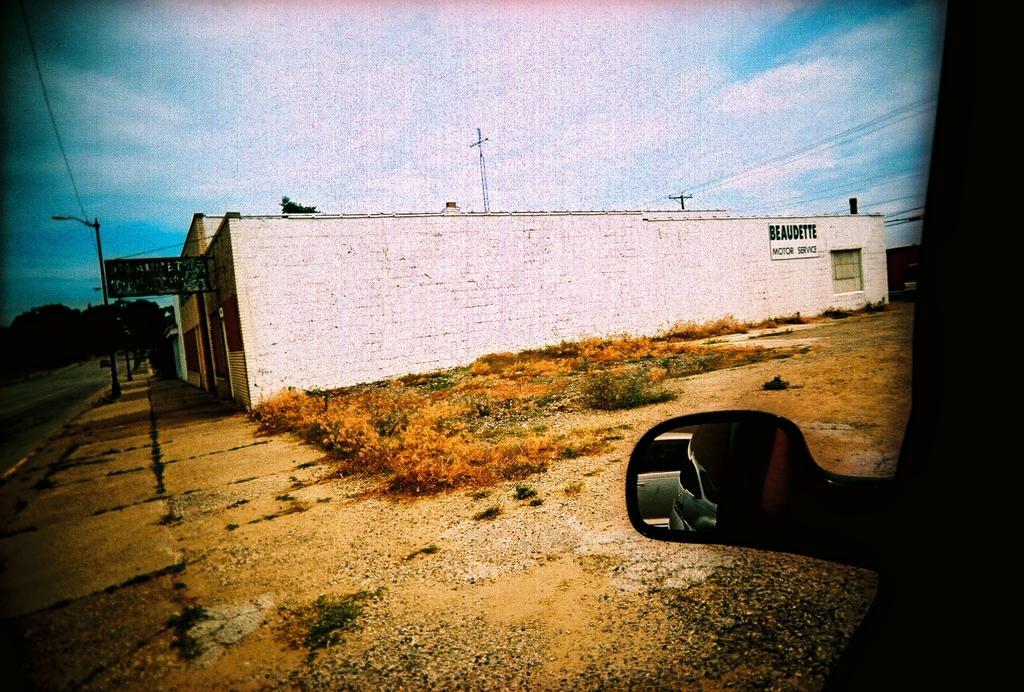How would you summarize this image in a sentence or two? At the center of the image there is a building, beside the building there are plants. On the left side of the image there is a road and trees. On the right side there is a mirror of a vehicle. In the background there is a sky. 